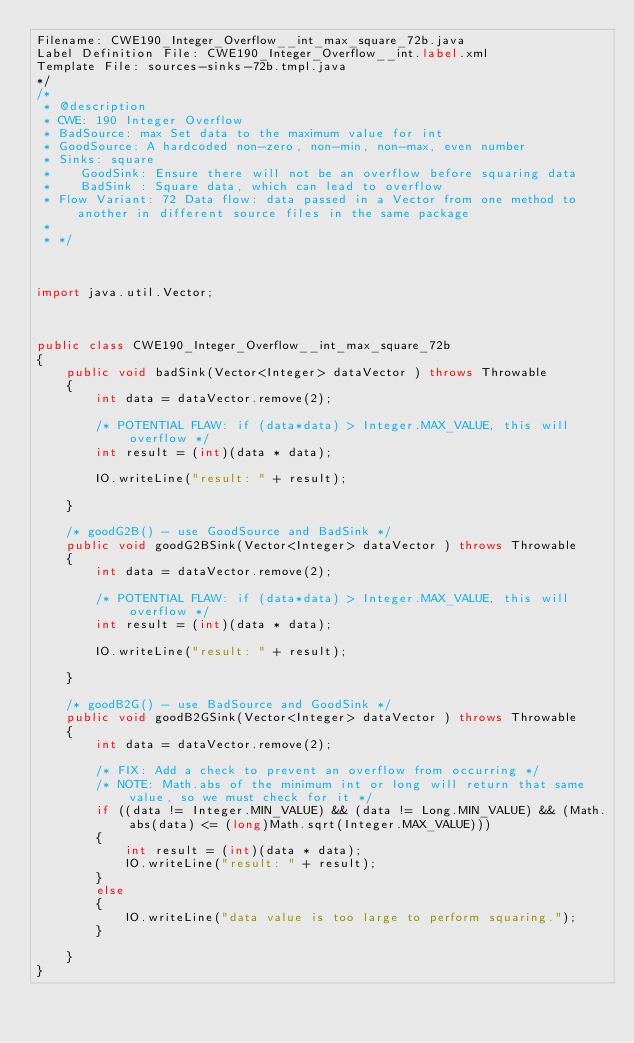Convert code to text. <code><loc_0><loc_0><loc_500><loc_500><_Java_>Filename: CWE190_Integer_Overflow__int_max_square_72b.java
Label Definition File: CWE190_Integer_Overflow__int.label.xml
Template File: sources-sinks-72b.tmpl.java
*/
/*
 * @description
 * CWE: 190 Integer Overflow
 * BadSource: max Set data to the maximum value for int
 * GoodSource: A hardcoded non-zero, non-min, non-max, even number
 * Sinks: square
 *    GoodSink: Ensure there will not be an overflow before squaring data
 *    BadSink : Square data, which can lead to overflow
 * Flow Variant: 72 Data flow: data passed in a Vector from one method to another in different source files in the same package
 *
 * */



import java.util.Vector;



public class CWE190_Integer_Overflow__int_max_square_72b
{
    public void badSink(Vector<Integer> dataVector ) throws Throwable
    {
        int data = dataVector.remove(2);

        /* POTENTIAL FLAW: if (data*data) > Integer.MAX_VALUE, this will overflow */
        int result = (int)(data * data);

        IO.writeLine("result: " + result);

    }

    /* goodG2B() - use GoodSource and BadSink */
    public void goodG2BSink(Vector<Integer> dataVector ) throws Throwable
    {
        int data = dataVector.remove(2);

        /* POTENTIAL FLAW: if (data*data) > Integer.MAX_VALUE, this will overflow */
        int result = (int)(data * data);

        IO.writeLine("result: " + result);

    }

    /* goodB2G() - use BadSource and GoodSink */
    public void goodB2GSink(Vector<Integer> dataVector ) throws Throwable
    {
        int data = dataVector.remove(2);

        /* FIX: Add a check to prevent an overflow from occurring */
        /* NOTE: Math.abs of the minimum int or long will return that same value, so we must check for it */
        if ((data != Integer.MIN_VALUE) && (data != Long.MIN_VALUE) && (Math.abs(data) <= (long)Math.sqrt(Integer.MAX_VALUE)))
        {
            int result = (int)(data * data);
            IO.writeLine("result: " + result);
        }
        else
        {
            IO.writeLine("data value is too large to perform squaring.");
        }

    }
}
</code> 